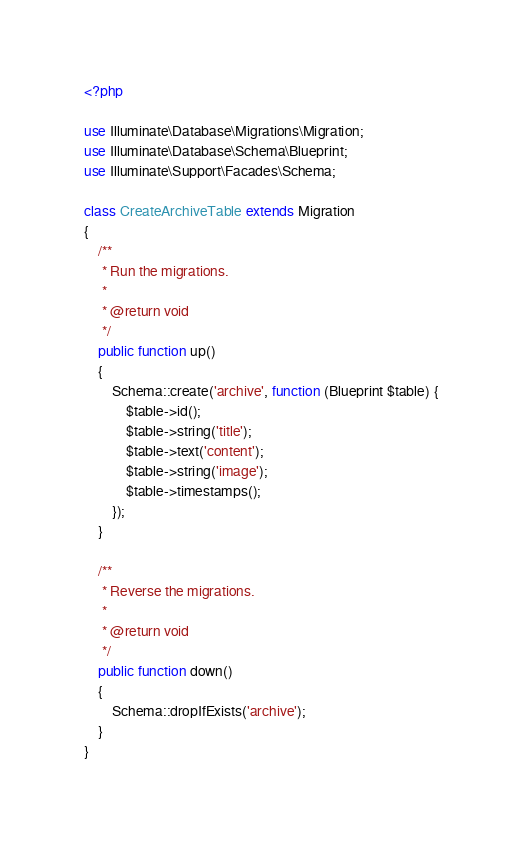Convert code to text. <code><loc_0><loc_0><loc_500><loc_500><_PHP_><?php

use Illuminate\Database\Migrations\Migration;
use Illuminate\Database\Schema\Blueprint;
use Illuminate\Support\Facades\Schema;

class CreateArchiveTable extends Migration
{
    /**
     * Run the migrations.
     *
     * @return void
     */
    public function up()
    {
        Schema::create('archive', function (Blueprint $table) {
            $table->id();
            $table->string('title'); 
            $table->text('content');
            $table->string('image');
            $table->timestamps();
        });
    }

    /**
     * Reverse the migrations.
     *
     * @return void
     */
    public function down()
    {
        Schema::dropIfExists('archive');
    }
}
</code> 